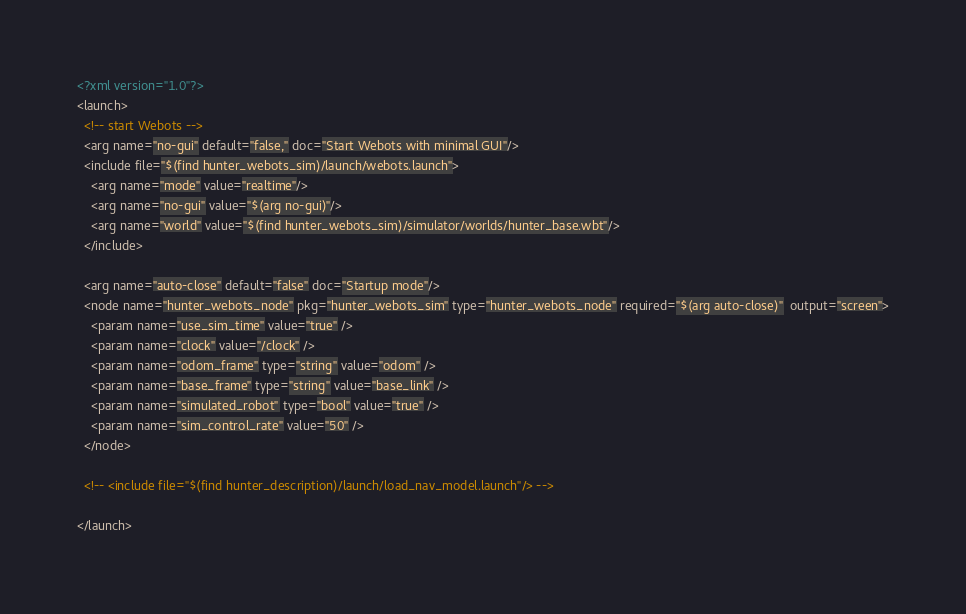<code> <loc_0><loc_0><loc_500><loc_500><_XML_><?xml version="1.0"?>
<launch>
  <!-- start Webots -->
  <arg name="no-gui" default="false," doc="Start Webots with minimal GUI"/>
  <include file="$(find hunter_webots_sim)/launch/webots.launch">
    <arg name="mode" value="realtime"/>
    <arg name="no-gui" value="$(arg no-gui)"/>
    <arg name="world" value="$(find hunter_webots_sim)/simulator/worlds/hunter_base.wbt"/>
  </include>

  <arg name="auto-close" default="false" doc="Startup mode"/>
  <node name="hunter_webots_node" pkg="hunter_webots_sim" type="hunter_webots_node" required="$(arg auto-close)"  output="screen">
    <param name="use_sim_time" value="true" />
    <param name="clock" value="/clock" />
    <param name="odom_frame" type="string" value="odom" />
    <param name="base_frame" type="string" value="base_link" />
    <param name="simulated_robot" type="bool" value="true" />
    <param name="sim_control_rate" value="50" />
  </node>

  <!-- <include file="$(find hunter_description)/launch/load_nav_model.launch"/> -->

</launch>
</code> 